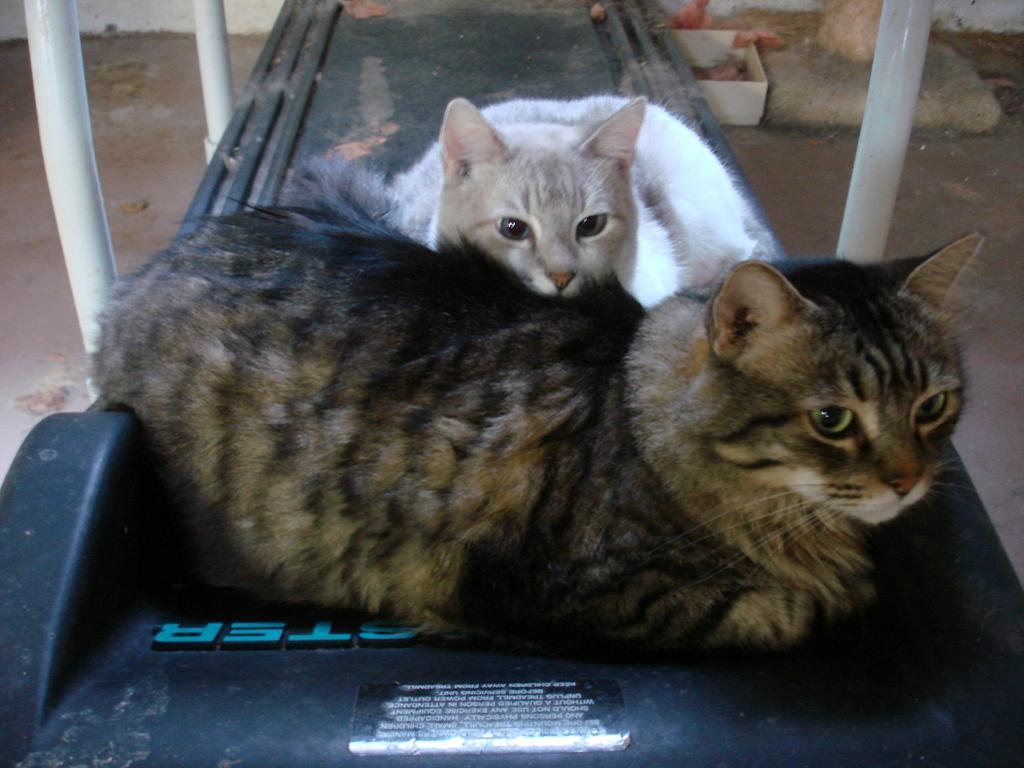How would you summarize this image in a sentence or two? In this image, there is a black color way, on that there is a black color and a white color cat sitting. 